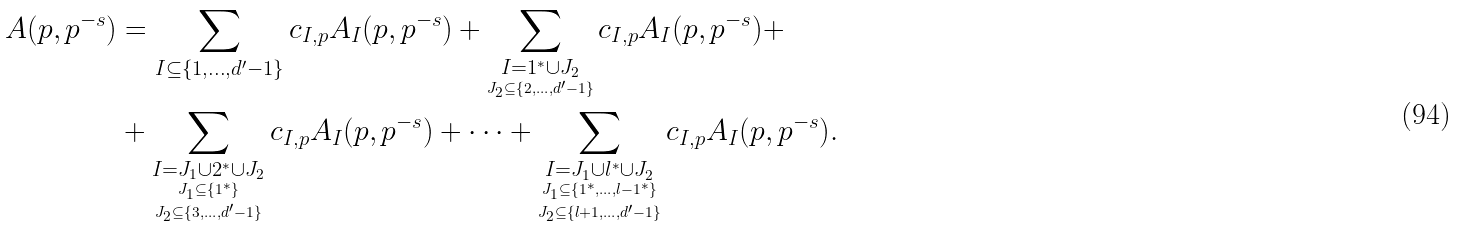Convert formula to latex. <formula><loc_0><loc_0><loc_500><loc_500>A ( p , p ^ { - s } ) & = \sum _ { I \subseteq \{ 1 , \dots , d ^ { \prime } - 1 \} } c _ { I , p } A _ { I } ( p , p ^ { - s } ) + \sum _ { \underset { J _ { 2 } \subseteq \{ 2 , \dots , d ^ { \prime } - 1 \} } { I = 1 ^ { * } \cup J _ { 2 } } } c _ { I , p } A _ { I } ( p , p ^ { - s } ) + \\ & + \sum _ { \underset { J _ { 2 } \subseteq \{ 3 , \dots , d ^ { \prime } - 1 \} } { \underset { J _ { 1 } \subseteq \{ 1 ^ { * } \} } { I = J _ { 1 } \cup 2 ^ { * } \cup J _ { 2 } } } } c _ { I , p } A _ { I } ( p , p ^ { - s } ) + \dots + \sum _ { \underset { J _ { 2 } \subseteq \{ l + 1 , \dots , d ^ { \prime } - 1 \} } { \underset { J _ { 1 } \subseteq \{ 1 ^ { * } , \dots , l - 1 ^ { * } \} } { I = J _ { 1 } \cup l ^ { * } \cup J _ { 2 } } } } c _ { I , p } A _ { I } ( p , p ^ { - s } ) .</formula> 